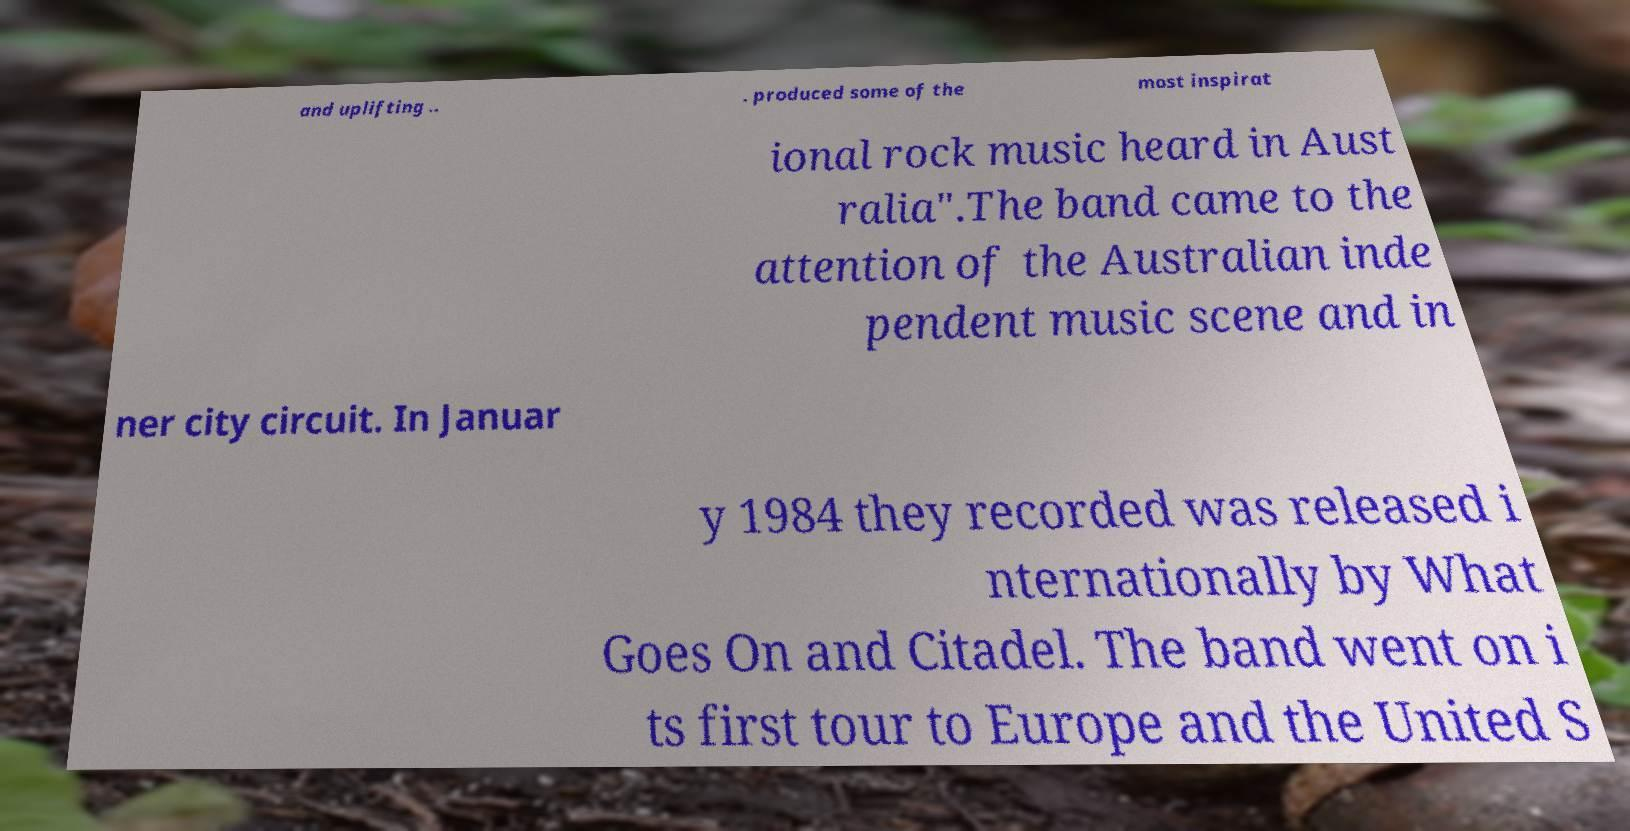What messages or text are displayed in this image? I need them in a readable, typed format. and uplifting .. . produced some of the most inspirat ional rock music heard in Aust ralia".The band came to the attention of the Australian inde pendent music scene and in ner city circuit. In Januar y 1984 they recorded was released i nternationally by What Goes On and Citadel. The band went on i ts first tour to Europe and the United S 